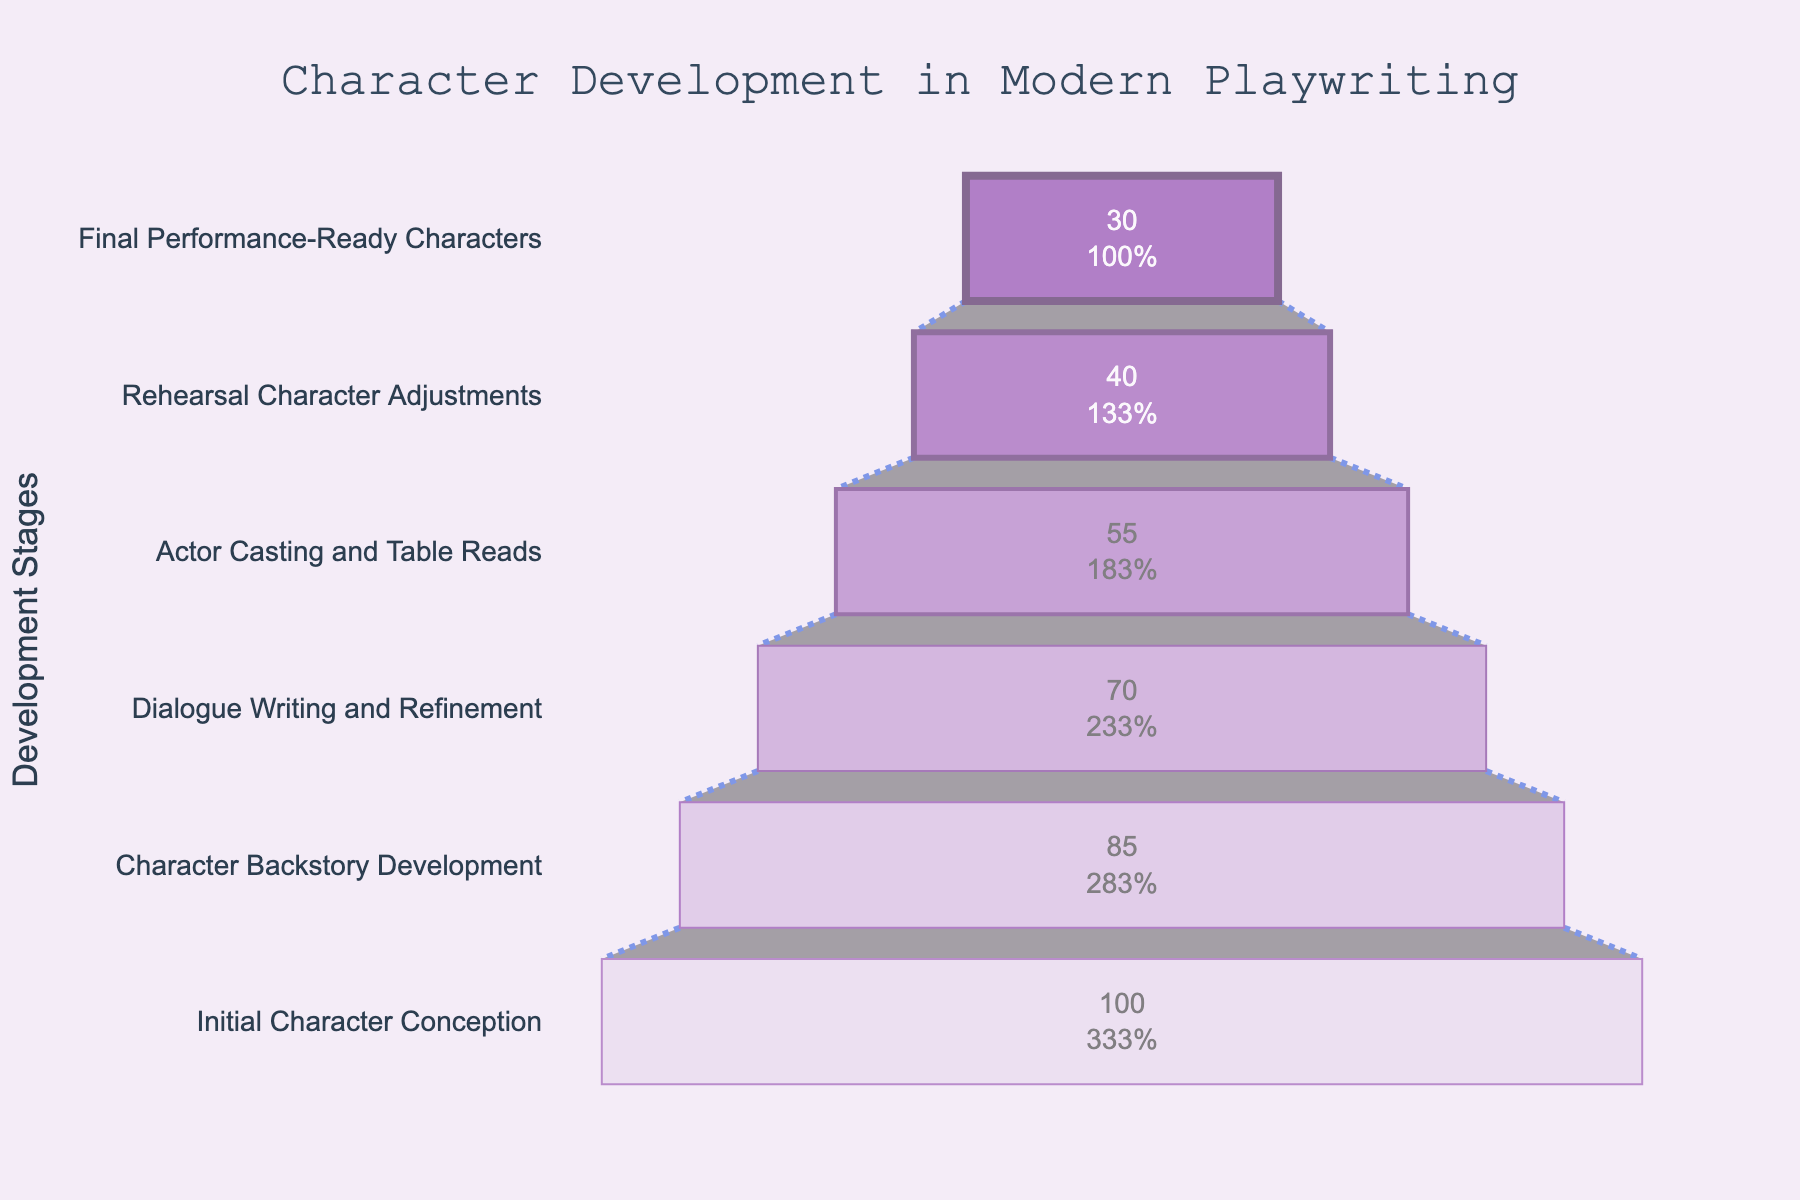What is the title of the funnel chart? The title is located at the top of the chart and is usually the most prominent text. It reads "Character Development in Modern Playwriting".
Answer: Character Development in Modern Playwriting How many stages are represented in the chart? Count the different stages listed on the y-axis. There are six stages to count.
Answer: Six stages Which stage has the highest number of characters? Look at the topmost part of the funnel where the number of characters is the highest. The stage "Initial Character Conception" has 100 characters.
Answer: Initial Character Conception By how many characters does the count drop from the "Actor Casting and Table Reads" stage to the "Rehearsal Character Adjustments" stage? The "Actor Casting and Table Reads" stage has 55 characters, and the "Rehearsal Character Adjustments" stage has 40 characters. Subtract the latter from the former: 55 - 40 = 15.
Answer: 15 What percentage of the initial characters remain at the "Final Performance-Ready Characters" stage? There are 100 characters initially and 30 at the final stage. The percentage remaining would be (30/100) * 100.
Answer: 30% Which stage has the smallest character drop compared to the previous stage? Look at the differences between successive stages: from "Initial Character Conception" to "Character Backstory Development" (100-85), from "Character Backstory Development" to "Dialogue Writing and Refinement" (85-70), and so on. The smallest drop is from "Rehearsal Character Adjustments" (40) to "Final Performance-Ready Characters" (30), which is 10 characters.
Answer: Final Performance-Ready Characters What is the color of the stage with 55 characters? Refer to the color scheme of the markers. The stage "Actor Casting and Table Reads" is marked in a lighter purple shade, specifically between the colors "#AF7AC5" and "#C39BD3".
Answer: A light purple shade How many characters are lost between "Dialogue Writing and Refinement" and "Actor Casting and Table Reads"? There are 70 characters during "Dialogue Writing and Refinement" and 55 during "Actor Casting and Table Reads". Subtract the latter from the former: 70 - 55.
Answer: 15 Which stage has a character count closest to the median character count across all stages? The character counts are 100, 85, 70, 55, 40, and 30. The median character count is the average of the third and fourth values (70+55)/2 = 62.5. "Actor Casting and Table Reads" with 55 characters is closest to this median.
Answer: Actor Casting and Table Reads What is the cumulative drop in character count from the "Character Backstory Development" stage to the "Final Performance-Ready Characters" stage? Identify the cumulative drops: 85 - 70, 70 - 55, 55 - 40, 40 - 30. Add these: 15 + 15 + 15 + 10 = 55.
Answer: 55 